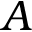Convert formula to latex. <formula><loc_0><loc_0><loc_500><loc_500>A</formula> 